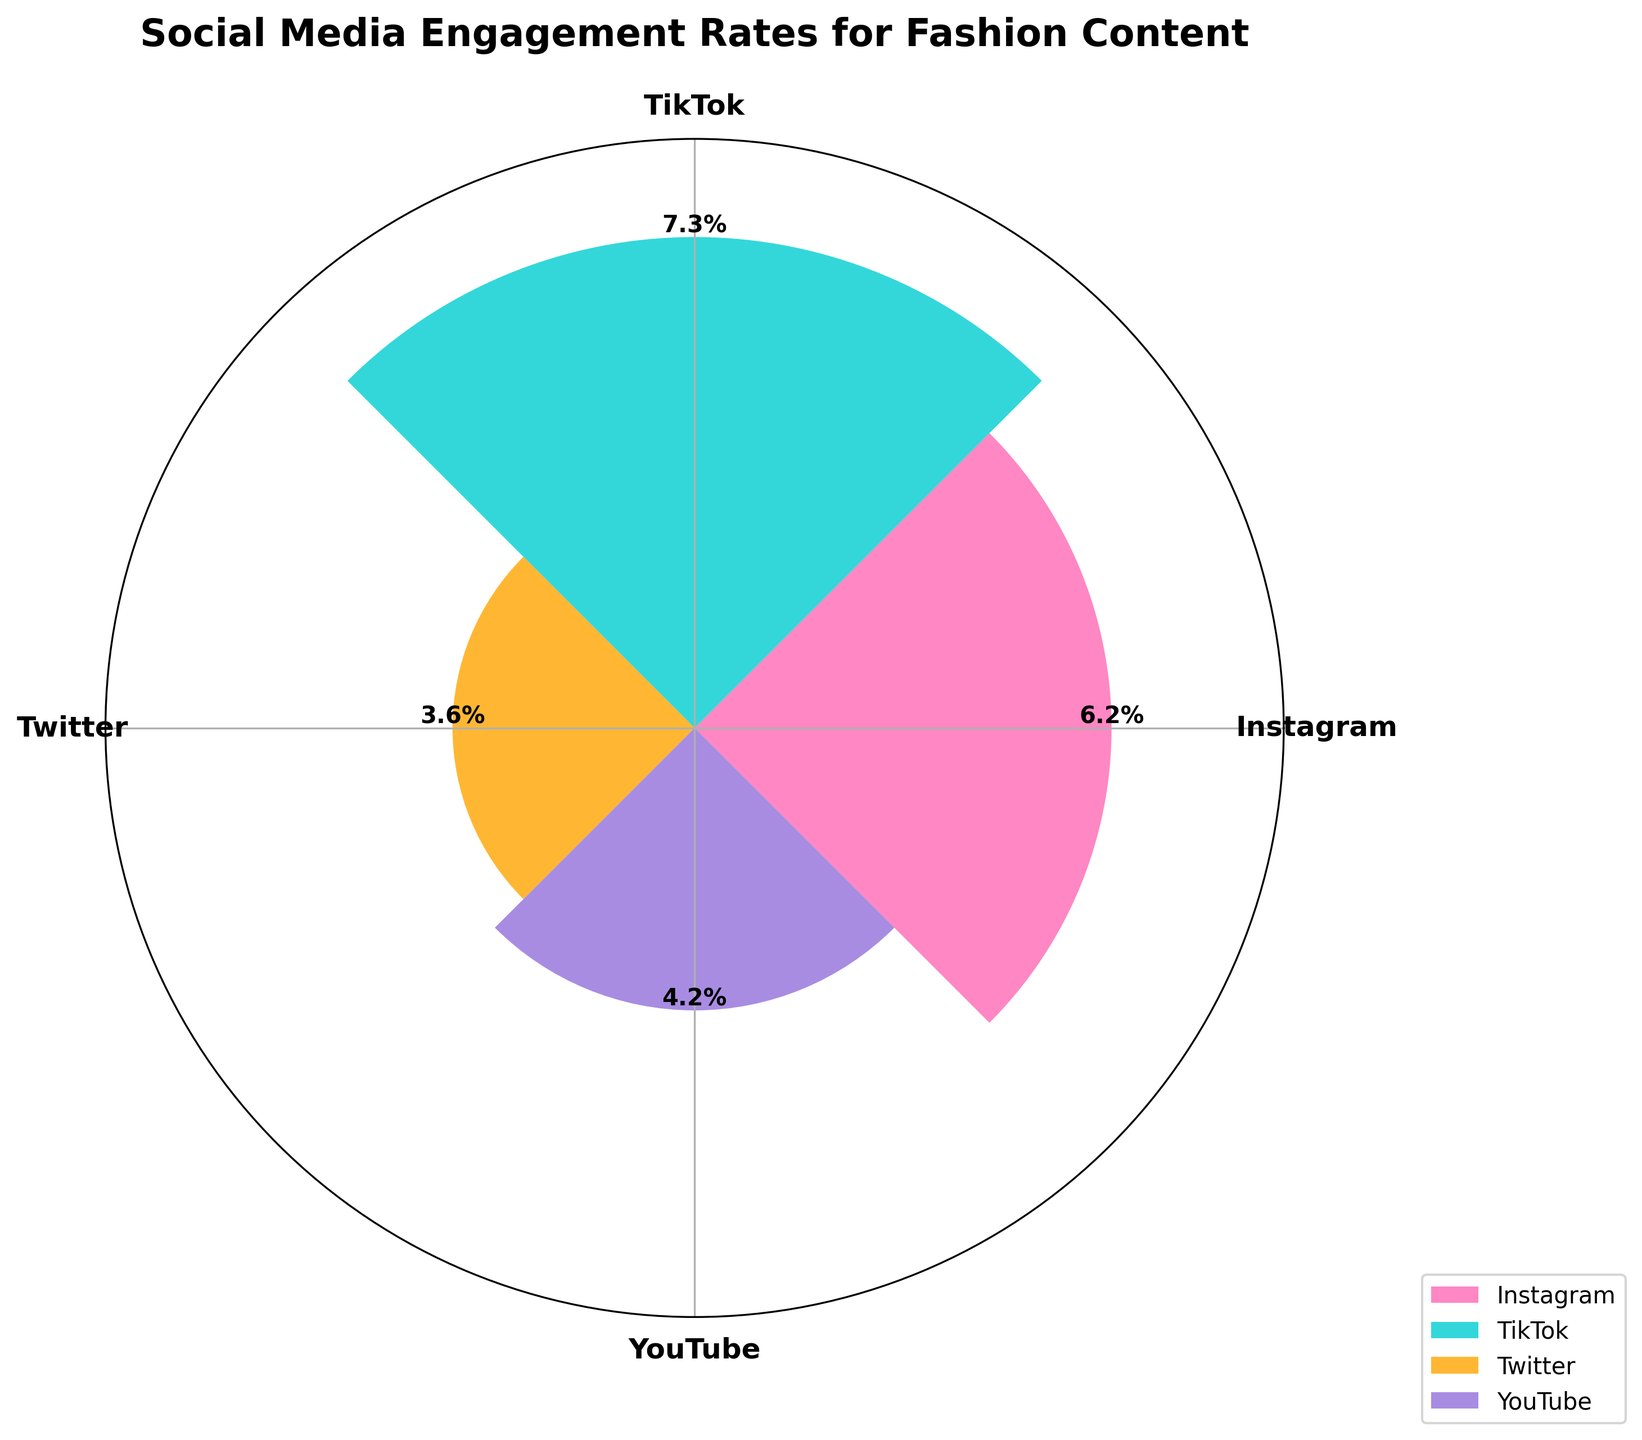What's the title of the figure? The title of the figure is typically found at the top. It is a text description that summarizes the main topic of the chart. In this case, the title is "Social Media Engagement Rates for Fashion Content".
Answer: Social Media Engagement Rates for Fashion Content How many platforms are compared in the figure? The number of platforms can be counted by looking at the distinct bars or sections in the rose chart. Here, there are four labeled sections: Instagram, TikTok, Twitter, and YouTube.
Answer: 4 Which platform has the highest engagement rate? To determine the platform with the highest engagement rate, we compare the heights of the bars representing each platform. The highest bar corresponds to the highest engagement rate, which is TikTok.
Answer: TikTok What's the combined engagement rate for YouTube? To find the combined engagement rate for YouTube, we sum its engagement rates for likes, comments, and shares. These values are 3.1%, 0.7%, and 0.4%, respectively. So, 3.1 + 0.7 + 0.4 = 4.2%.
Answer: 4.2% Which platform has the lowest overall engagement rate? By comparing the heights of the bars, we identify the platform with the shortest bar. This indicates the lowest combined engagement rate, which is for Twitter.
Answer: Twitter How does Instagram's engagement rate for shares compare to TikTok's? We compare the engagement rate for shares between Instagram (0.5%) and TikTok (1.2%). TikTok has a higher rate.
Answer: TikTok has a higher rate What's the difference between Instagram's and Twitter's total engagement rates? First, we find the total engagement rates for Instagram (4.8% + 0.9% + 0.5% = 6.2%) and Twitter (2.3% + 0.4% + 0.9% = 3.6%). The difference is 6.2% - 3.6% = 2.6%.
Answer: 2.6% List the platforms in descending order of engagement rates. To list them, we compare the total engagement rates: TikTok (7.3%), Instagram (6.2%), YouTube (4.2%), and Twitter (3.6%), and arrange them from highest to lowest.
Answer: TikTok, Instagram, YouTube, Twitter How much higher is TikTok's engagement rate compared to YouTube's? TikTok's total engagement rate is 7.3%, and YouTube's is 4.2%. The difference is 7.3% - 4.2% = 3.1%.
Answer: 3.1% Which platform is closest in engagement rate to Instagram? By comparing total engagement rates, we see that YouTube (4.2%) is closest to Instagram (6.2%) compared to the others.
Answer: YouTube 